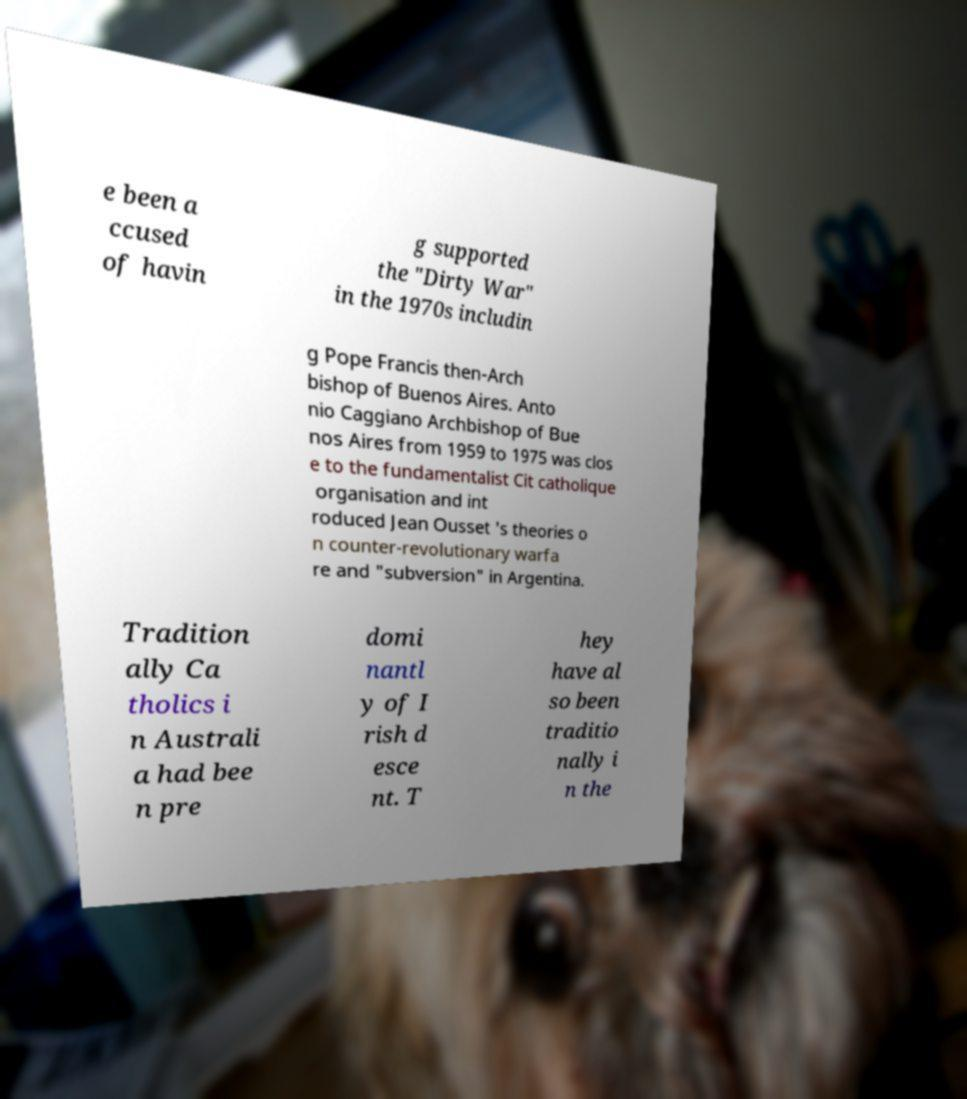Please read and relay the text visible in this image. What does it say? e been a ccused of havin g supported the "Dirty War" in the 1970s includin g Pope Francis then-Arch bishop of Buenos Aires. Anto nio Caggiano Archbishop of Bue nos Aires from 1959 to 1975 was clos e to the fundamentalist Cit catholique organisation and int roduced Jean Ousset 's theories o n counter-revolutionary warfa re and "subversion" in Argentina. Tradition ally Ca tholics i n Australi a had bee n pre domi nantl y of I rish d esce nt. T hey have al so been traditio nally i n the 